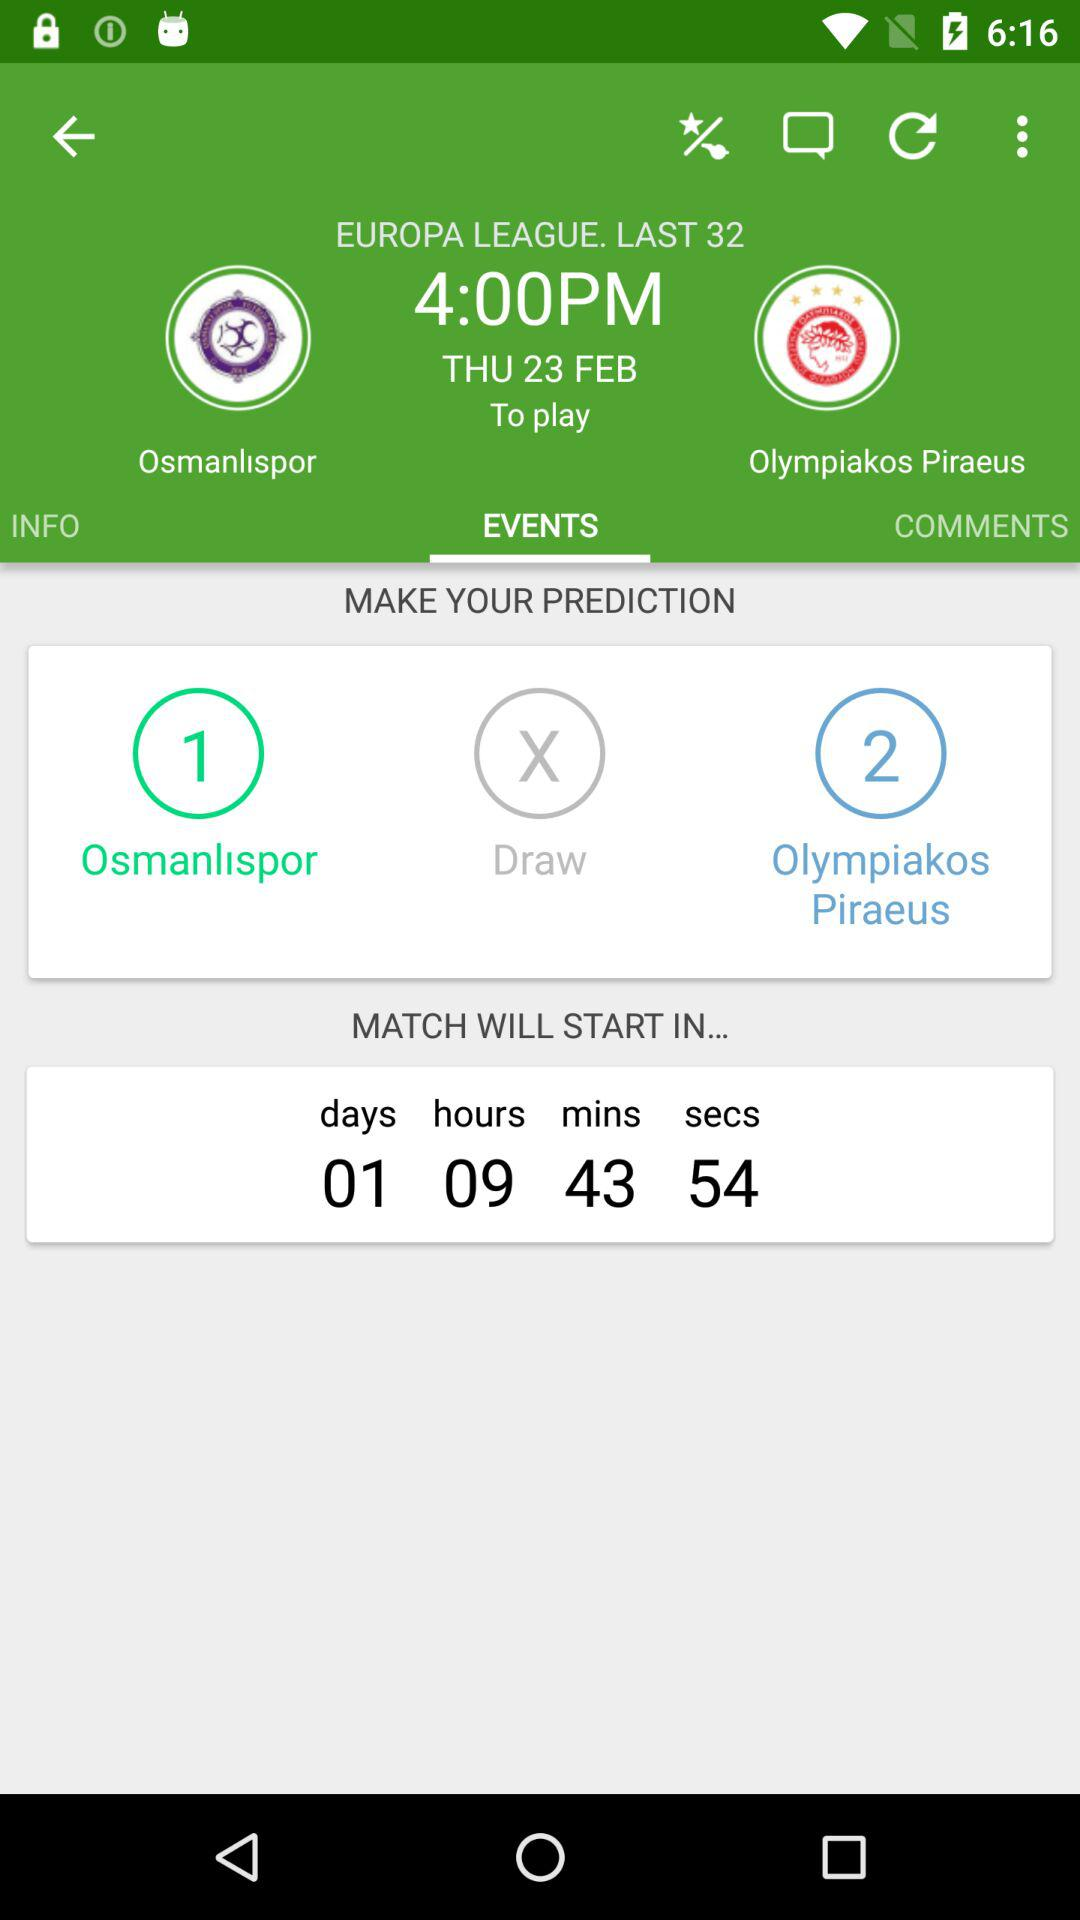How long will it take for the match to start? The match will start in 1 day, 09 hours, 43 minutes, and 54 seconds. 